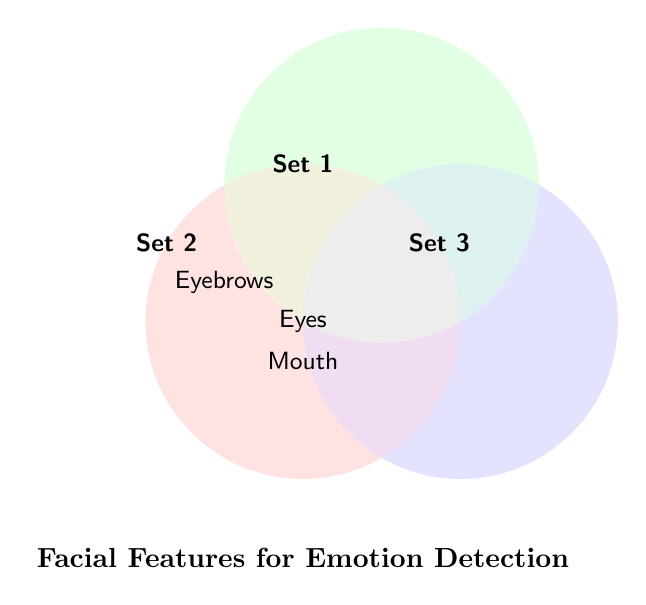What is the title of the Venn Diagram? The title of the figure is located at the bottom and it states the main subject of the Venn Diagram.
Answer: Facial Features for Emotion Detection What facial features are common across all three sets? Find the features that appear in the overlap of all three circles.
Answer: Eyes, Mouth Which facial feature is unique to Set 2? Determine which feature only appears in the location of Set 2 and nowhere else.
Answer: None Are there any facial features unique to Set 3? Check the portions of Set 3 that do not overlap with other sets.
Answer: None How many distinct facial features are listed in the Venn Diagram? Count the unique facial features present in the diagram, excluding repetitions.
Answer: 3 Which set has the most unique facial features? Compare each set to see which has the highest count of non-shared features.
Answer: Set 1 What feature is shared between Set 1 and Set 2 but not Set 3? Observe the overlapping section between Set 1 and Set 2 but not overlapping with Set 3.
Answer: None Which facial features are only shared between Set 1 and Set 3, but not Set 2? Identify the features found in the overlapping area between Set 1 and Set 3 but not in Set 2.
Answer: None Is there any feature that appears in exactly two sets? Check for features that are present in the intersection of any two sets but not in the third one.
Answer: Eyebrows What insights can be drawn about the importance of the 'Eyes' feature in emotion detection from this Venn Diagram? Considering that 'Eyes' is a common feature shared by all three sets, it can be deduced that it is crucial for emotion detection.
Answer: Eyes is crucial for emotion detection 